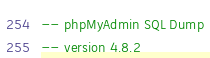<code> <loc_0><loc_0><loc_500><loc_500><_SQL_>-- phpMyAdmin SQL Dump
-- version 4.8.2</code> 